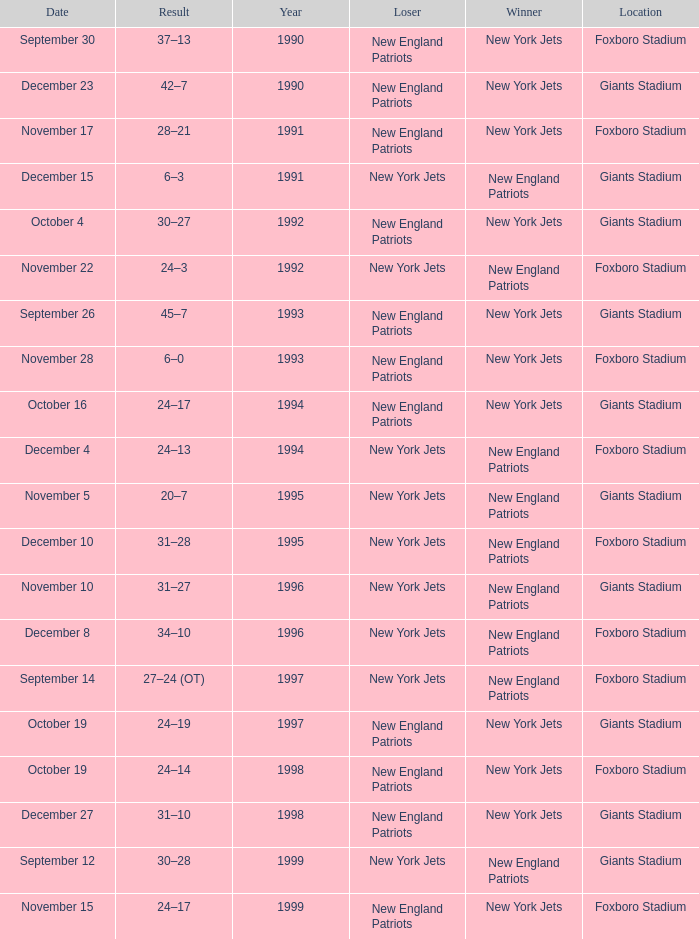What team was the lower when the winner was the new york jets, and a Year earlier than 1994, and a Result of 37–13? New England Patriots. 